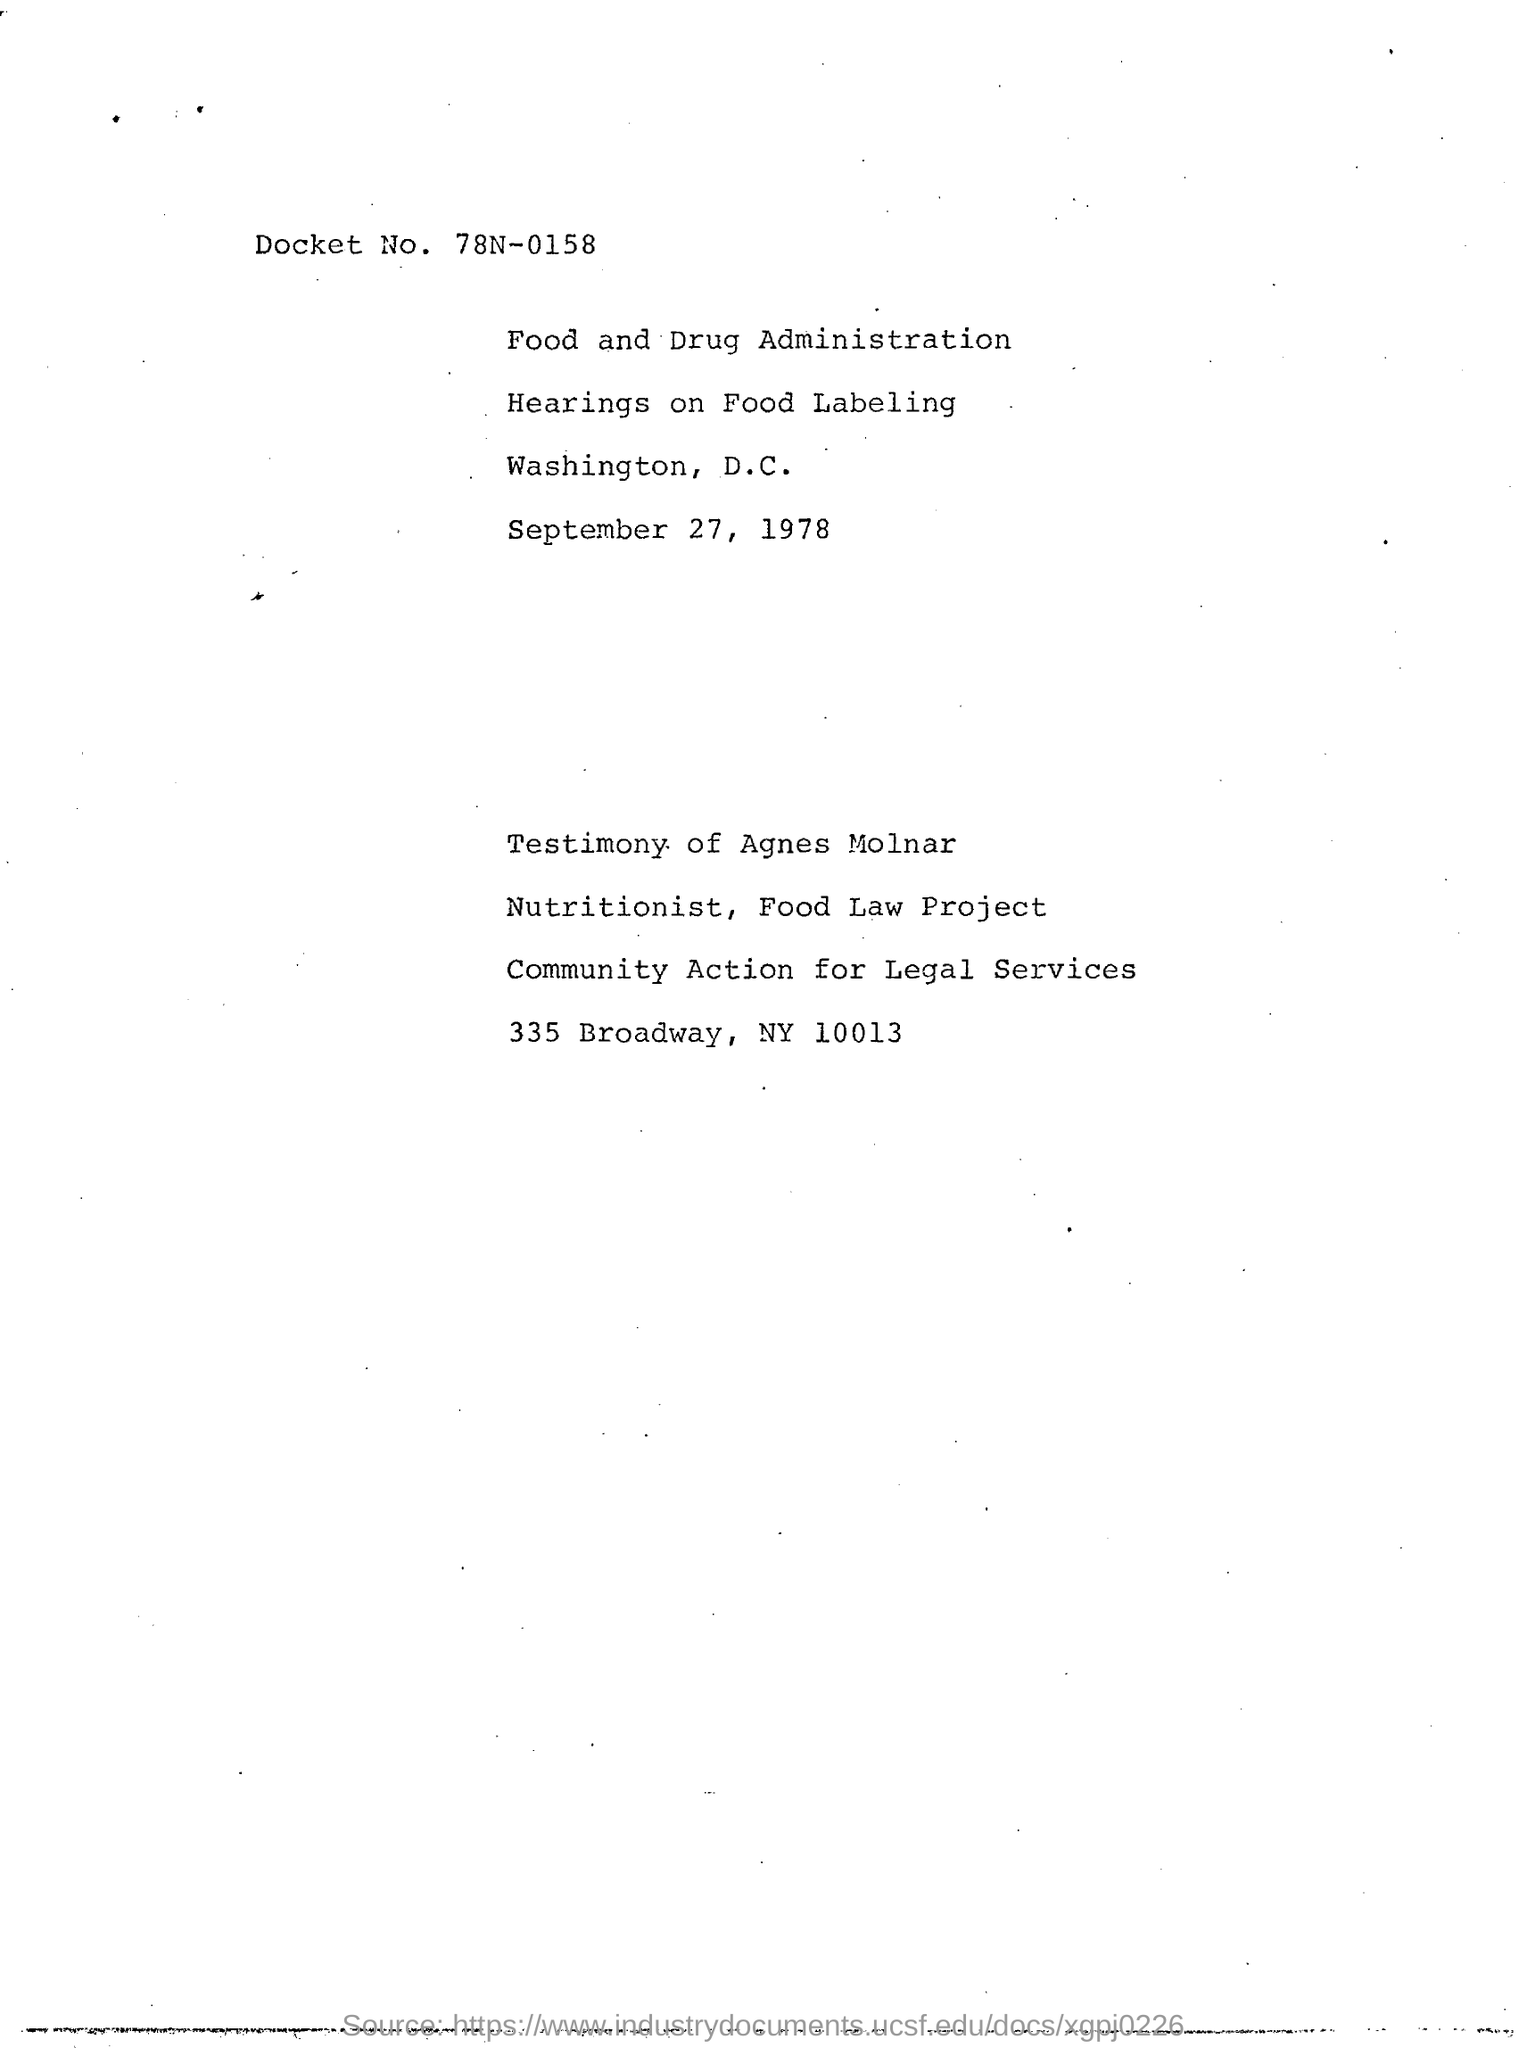What is the docket No?
Provide a succinct answer. 78N-0158. What is the date in document?
Provide a short and direct response. September 27, 1978. 